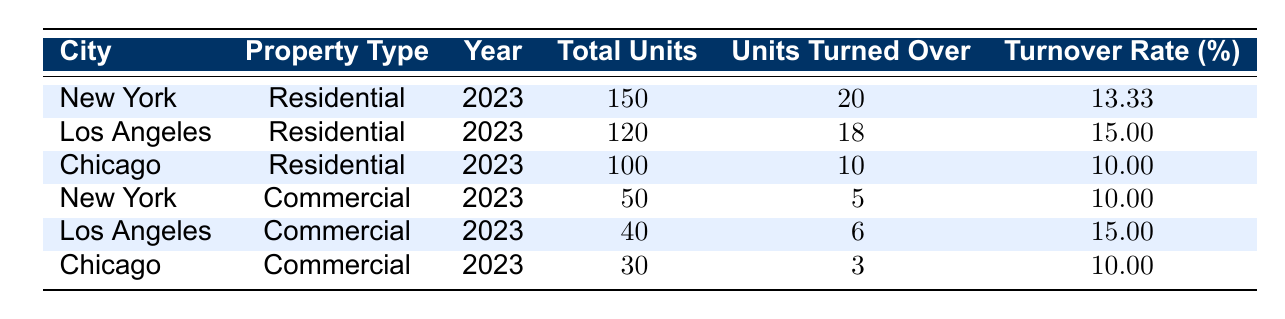What is the tenant turnover rate for residential properties in Los Angeles? The table shows that the turnover rate for residential properties in Los Angeles is listed in the row for that city and property type. It states 15.00.
Answer: 15.00 What was the total number of units turned over in Chicago for commercial properties? In the table, the row for commercial properties in Chicago indicates that 3 units were turned over.
Answer: 3 Which property type had a higher average turnover rate? First, calculate the average turnover rate for residential properties: (13.33 + 15.00 + 10.00) / 3 = 12.78. Then calculate for commercial: (10.00 + 15.00 + 10.00) / 3 = 11.67. Since 12.78 > 11.67, residential properties had a higher average turnover rate.
Answer: Residential Is the turnover rate for commercial properties in New York higher than that of Chicago? The table indicates that the turnover rate for commercial properties in New York is 10.00%, while in Chicago it is also 10.00%. Since both rates are equal, the answer is no.
Answer: No What is the total number of units in all residential properties listed? Add up the total units from the residential properties: 150 (New York) + 120 (Los Angeles) + 100 (Chicago) = 370.
Answer: 370 What city has the lowest tenant turnover rate for residential properties? By examining the turnover rates in the residential section, we see that Chicago has the lowest rate at 10.00%.
Answer: Chicago What is the difference in turnover rates between the highest and lowest for all property types? The highest turnover rate is 15.00% (Los Angeles residential, and Los Angeles commercial), and the lowest is 10.00% (New York commercial, Chicago commercial). The difference is 15.00 - 10.00 = 5.00%.
Answer: 5.00 Which city has the highest turnover rate for commercial properties, and what is that rate? The commercial turnover rates are 10.00% for New York, 15.00% for Los Angeles, and 10.00% for Chicago. The highest is 15.00% for Los Angeles.
Answer: Los Angeles, 15.00 